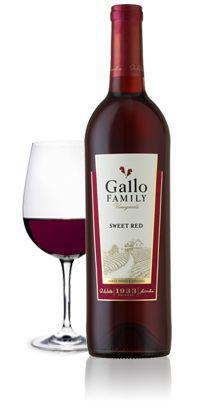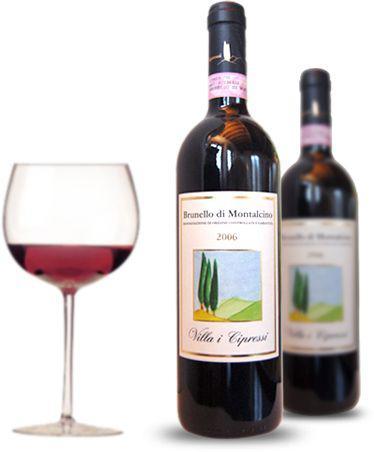The first image is the image on the left, the second image is the image on the right. Examine the images to the left and right. Is the description "There is exactly one wineglass sitting on the left side of the bottle in the image on the left." accurate? Answer yes or no. Yes. The first image is the image on the left, the second image is the image on the right. Considering the images on both sides, is "One of the bottles of wine is green and sits near a pile of grapes." valid? Answer yes or no. No. 